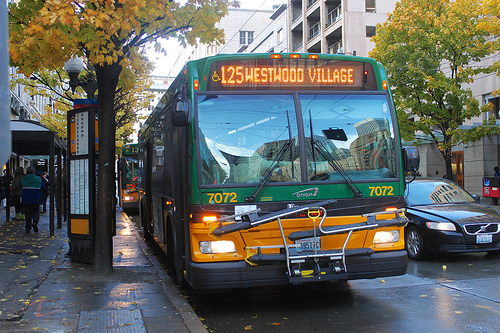What kind of vehicle is to the right of the man that is walking down the sidewalk? To the right of the man walking down the sidewalk, there's a city bus, serving as a practical mode of transportation in this urban scene. 